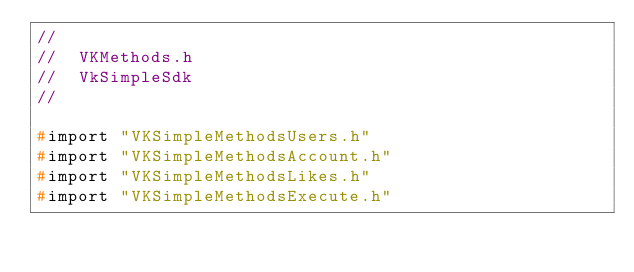Convert code to text. <code><loc_0><loc_0><loc_500><loc_500><_C_>//
//  VKMethods.h
//  VkSimpleSdk
//

#import "VKSimpleMethodsUsers.h"
#import "VKSimpleMethodsAccount.h"
#import "VKSimpleMethodsLikes.h"
#import "VKSimpleMethodsExecute.h"
</code> 